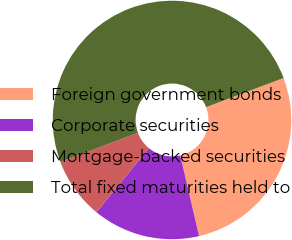Convert chart. <chart><loc_0><loc_0><loc_500><loc_500><pie_chart><fcel>Foreign government bonds<fcel>Corporate securities<fcel>Mortgage-backed securities<fcel>Total fixed maturities held to<nl><fcel>27.08%<fcel>14.58%<fcel>8.33%<fcel>50.0%<nl></chart> 